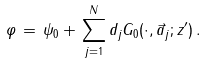Convert formula to latex. <formula><loc_0><loc_0><loc_500><loc_500>\varphi \, = \, \psi _ { 0 } + \, \sum _ { j = 1 } ^ { N } d _ { j } G _ { 0 } ( \cdot , \vec { a } _ { j } ; z ^ { \prime } ) \, .</formula> 